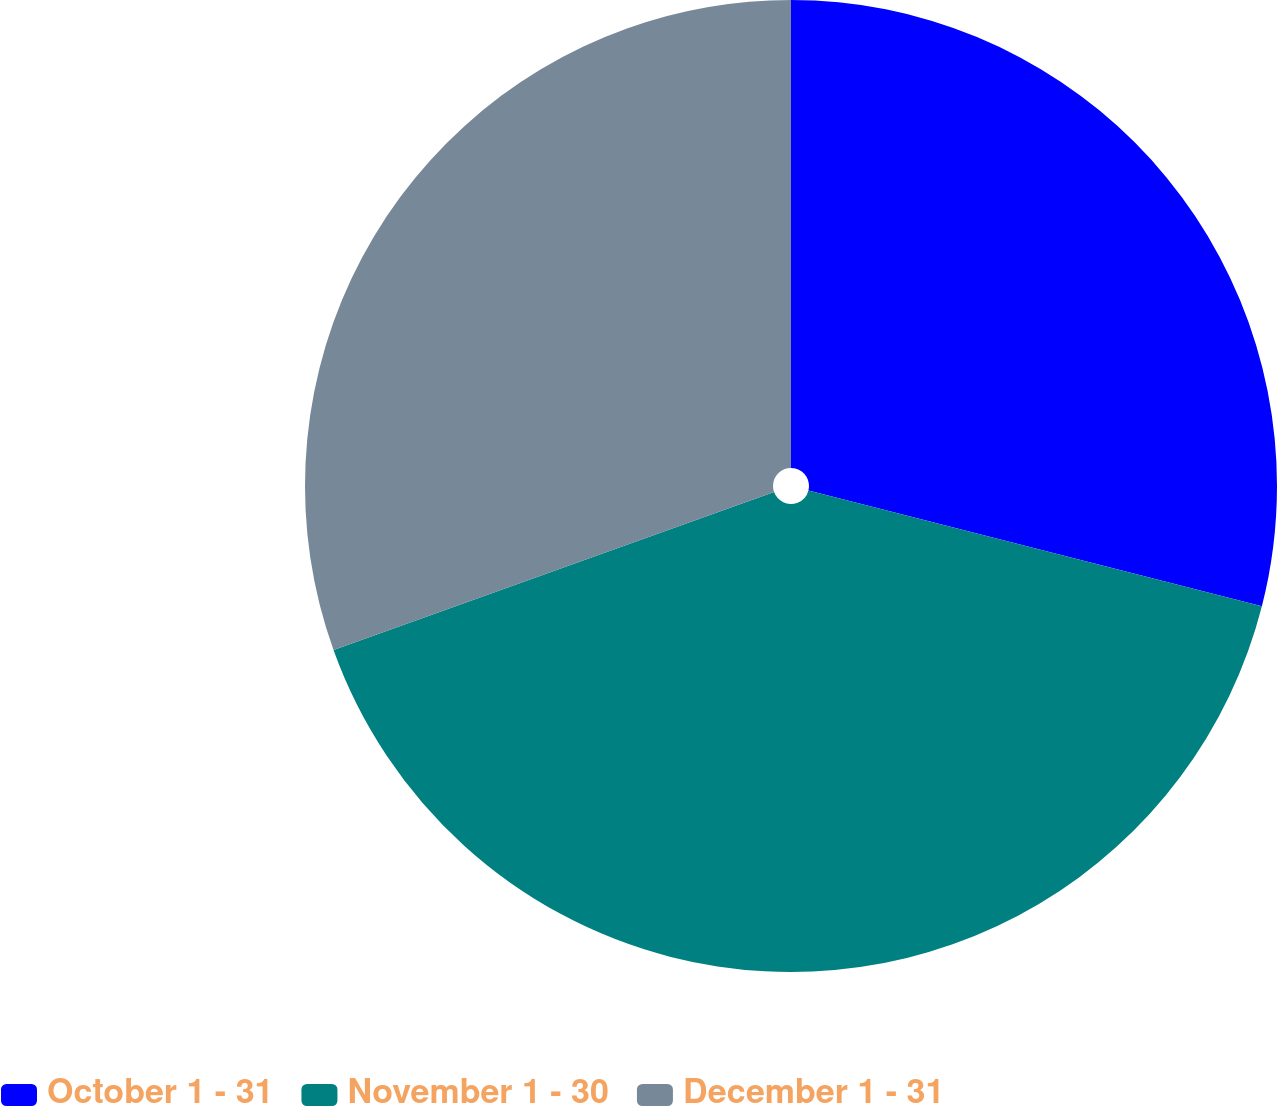Convert chart to OTSL. <chart><loc_0><loc_0><loc_500><loc_500><pie_chart><fcel>October 1 - 31<fcel>November 1 - 30<fcel>December 1 - 31<nl><fcel>28.98%<fcel>40.54%<fcel>30.48%<nl></chart> 